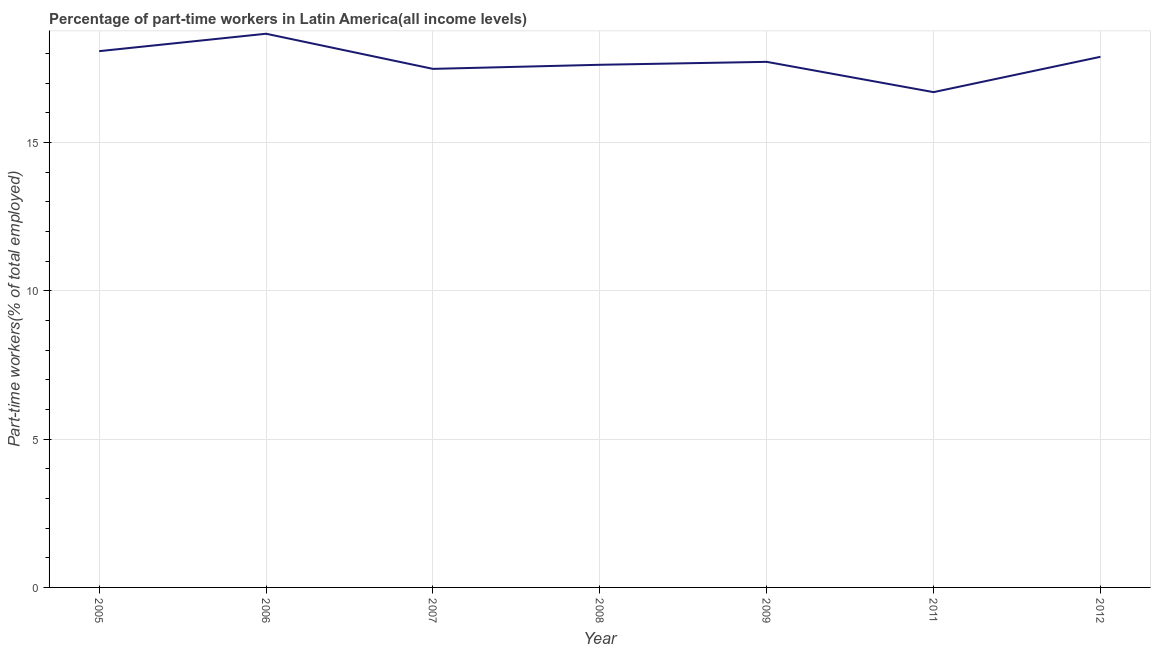What is the percentage of part-time workers in 2012?
Your answer should be compact. 17.89. Across all years, what is the maximum percentage of part-time workers?
Your answer should be very brief. 18.67. Across all years, what is the minimum percentage of part-time workers?
Your answer should be very brief. 16.7. In which year was the percentage of part-time workers maximum?
Provide a succinct answer. 2006. In which year was the percentage of part-time workers minimum?
Your answer should be very brief. 2011. What is the sum of the percentage of part-time workers?
Make the answer very short. 124.16. What is the difference between the percentage of part-time workers in 2006 and 2007?
Make the answer very short. 1.18. What is the average percentage of part-time workers per year?
Your answer should be very brief. 17.74. What is the median percentage of part-time workers?
Give a very brief answer. 17.72. What is the ratio of the percentage of part-time workers in 2007 to that in 2011?
Provide a short and direct response. 1.05. What is the difference between the highest and the second highest percentage of part-time workers?
Your answer should be very brief. 0.59. Is the sum of the percentage of part-time workers in 2007 and 2012 greater than the maximum percentage of part-time workers across all years?
Keep it short and to the point. Yes. What is the difference between the highest and the lowest percentage of part-time workers?
Your answer should be compact. 1.97. In how many years, is the percentage of part-time workers greater than the average percentage of part-time workers taken over all years?
Your answer should be very brief. 3. Does the percentage of part-time workers monotonically increase over the years?
Your answer should be very brief. No. How many lines are there?
Make the answer very short. 1. What is the difference between two consecutive major ticks on the Y-axis?
Provide a short and direct response. 5. Are the values on the major ticks of Y-axis written in scientific E-notation?
Your answer should be very brief. No. Does the graph contain any zero values?
Your response must be concise. No. What is the title of the graph?
Provide a succinct answer. Percentage of part-time workers in Latin America(all income levels). What is the label or title of the X-axis?
Ensure brevity in your answer.  Year. What is the label or title of the Y-axis?
Ensure brevity in your answer.  Part-time workers(% of total employed). What is the Part-time workers(% of total employed) in 2005?
Make the answer very short. 18.08. What is the Part-time workers(% of total employed) of 2006?
Your answer should be compact. 18.67. What is the Part-time workers(% of total employed) in 2007?
Your answer should be very brief. 17.48. What is the Part-time workers(% of total employed) in 2008?
Your answer should be very brief. 17.62. What is the Part-time workers(% of total employed) of 2009?
Ensure brevity in your answer.  17.72. What is the Part-time workers(% of total employed) of 2011?
Your response must be concise. 16.7. What is the Part-time workers(% of total employed) of 2012?
Ensure brevity in your answer.  17.89. What is the difference between the Part-time workers(% of total employed) in 2005 and 2006?
Give a very brief answer. -0.59. What is the difference between the Part-time workers(% of total employed) in 2005 and 2007?
Ensure brevity in your answer.  0.6. What is the difference between the Part-time workers(% of total employed) in 2005 and 2008?
Provide a short and direct response. 0.46. What is the difference between the Part-time workers(% of total employed) in 2005 and 2009?
Ensure brevity in your answer.  0.36. What is the difference between the Part-time workers(% of total employed) in 2005 and 2011?
Ensure brevity in your answer.  1.38. What is the difference between the Part-time workers(% of total employed) in 2005 and 2012?
Your answer should be very brief. 0.19. What is the difference between the Part-time workers(% of total employed) in 2006 and 2007?
Give a very brief answer. 1.18. What is the difference between the Part-time workers(% of total employed) in 2006 and 2008?
Offer a terse response. 1.05. What is the difference between the Part-time workers(% of total employed) in 2006 and 2009?
Make the answer very short. 0.95. What is the difference between the Part-time workers(% of total employed) in 2006 and 2011?
Make the answer very short. 1.97. What is the difference between the Part-time workers(% of total employed) in 2006 and 2012?
Keep it short and to the point. 0.78. What is the difference between the Part-time workers(% of total employed) in 2007 and 2008?
Give a very brief answer. -0.14. What is the difference between the Part-time workers(% of total employed) in 2007 and 2009?
Your answer should be compact. -0.24. What is the difference between the Part-time workers(% of total employed) in 2007 and 2011?
Offer a very short reply. 0.78. What is the difference between the Part-time workers(% of total employed) in 2007 and 2012?
Ensure brevity in your answer.  -0.41. What is the difference between the Part-time workers(% of total employed) in 2008 and 2009?
Make the answer very short. -0.1. What is the difference between the Part-time workers(% of total employed) in 2008 and 2011?
Offer a very short reply. 0.92. What is the difference between the Part-time workers(% of total employed) in 2008 and 2012?
Provide a succinct answer. -0.27. What is the difference between the Part-time workers(% of total employed) in 2009 and 2011?
Offer a terse response. 1.02. What is the difference between the Part-time workers(% of total employed) in 2009 and 2012?
Keep it short and to the point. -0.17. What is the difference between the Part-time workers(% of total employed) in 2011 and 2012?
Ensure brevity in your answer.  -1.19. What is the ratio of the Part-time workers(% of total employed) in 2005 to that in 2006?
Ensure brevity in your answer.  0.97. What is the ratio of the Part-time workers(% of total employed) in 2005 to that in 2007?
Offer a very short reply. 1.03. What is the ratio of the Part-time workers(% of total employed) in 2005 to that in 2008?
Ensure brevity in your answer.  1.03. What is the ratio of the Part-time workers(% of total employed) in 2005 to that in 2009?
Offer a very short reply. 1.02. What is the ratio of the Part-time workers(% of total employed) in 2005 to that in 2011?
Offer a very short reply. 1.08. What is the ratio of the Part-time workers(% of total employed) in 2005 to that in 2012?
Give a very brief answer. 1.01. What is the ratio of the Part-time workers(% of total employed) in 2006 to that in 2007?
Keep it short and to the point. 1.07. What is the ratio of the Part-time workers(% of total employed) in 2006 to that in 2008?
Provide a succinct answer. 1.06. What is the ratio of the Part-time workers(% of total employed) in 2006 to that in 2009?
Offer a terse response. 1.05. What is the ratio of the Part-time workers(% of total employed) in 2006 to that in 2011?
Your answer should be compact. 1.12. What is the ratio of the Part-time workers(% of total employed) in 2006 to that in 2012?
Your response must be concise. 1.04. What is the ratio of the Part-time workers(% of total employed) in 2007 to that in 2009?
Keep it short and to the point. 0.99. What is the ratio of the Part-time workers(% of total employed) in 2007 to that in 2011?
Ensure brevity in your answer.  1.05. What is the ratio of the Part-time workers(% of total employed) in 2007 to that in 2012?
Keep it short and to the point. 0.98. What is the ratio of the Part-time workers(% of total employed) in 2008 to that in 2011?
Make the answer very short. 1.05. What is the ratio of the Part-time workers(% of total employed) in 2008 to that in 2012?
Give a very brief answer. 0.98. What is the ratio of the Part-time workers(% of total employed) in 2009 to that in 2011?
Provide a succinct answer. 1.06. What is the ratio of the Part-time workers(% of total employed) in 2009 to that in 2012?
Your answer should be compact. 0.99. What is the ratio of the Part-time workers(% of total employed) in 2011 to that in 2012?
Keep it short and to the point. 0.93. 